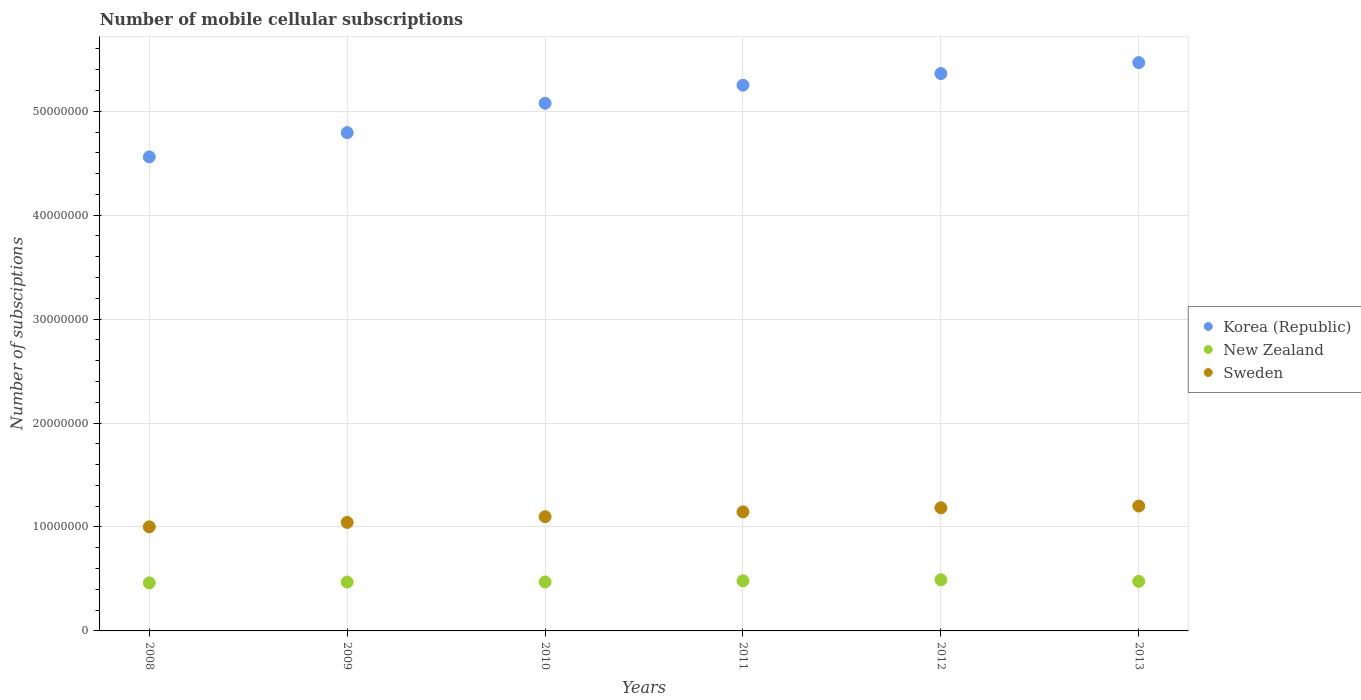What is the number of mobile cellular subscriptions in Sweden in 2013?
Provide a short and direct response. 1.20e+07. Across all years, what is the maximum number of mobile cellular subscriptions in New Zealand?
Your response must be concise. 4.92e+06. Across all years, what is the minimum number of mobile cellular subscriptions in Sweden?
Keep it short and to the point. 1.00e+07. In which year was the number of mobile cellular subscriptions in Korea (Republic) maximum?
Provide a succinct answer. 2013. What is the total number of mobile cellular subscriptions in Sweden in the graph?
Offer a terse response. 6.68e+07. What is the difference between the number of mobile cellular subscriptions in Korea (Republic) in 2010 and that in 2013?
Provide a succinct answer. -3.91e+06. What is the difference between the number of mobile cellular subscriptions in New Zealand in 2013 and the number of mobile cellular subscriptions in Sweden in 2009?
Offer a very short reply. -5.67e+06. What is the average number of mobile cellular subscriptions in Sweden per year?
Provide a short and direct response. 1.11e+07. In the year 2008, what is the difference between the number of mobile cellular subscriptions in Korea (Republic) and number of mobile cellular subscriptions in Sweden?
Your answer should be compact. 3.56e+07. What is the ratio of the number of mobile cellular subscriptions in New Zealand in 2008 to that in 2010?
Your response must be concise. 0.98. Is the number of mobile cellular subscriptions in Korea (Republic) in 2008 less than that in 2009?
Provide a succinct answer. Yes. Is the difference between the number of mobile cellular subscriptions in Korea (Republic) in 2009 and 2013 greater than the difference between the number of mobile cellular subscriptions in Sweden in 2009 and 2013?
Provide a succinct answer. No. What is the difference between the highest and the second highest number of mobile cellular subscriptions in Korea (Republic)?
Offer a terse response. 1.06e+06. What is the difference between the highest and the lowest number of mobile cellular subscriptions in Sweden?
Offer a very short reply. 2.00e+06. Is the sum of the number of mobile cellular subscriptions in Korea (Republic) in 2008 and 2012 greater than the maximum number of mobile cellular subscriptions in New Zealand across all years?
Ensure brevity in your answer.  Yes. Does the number of mobile cellular subscriptions in Sweden monotonically increase over the years?
Give a very brief answer. Yes. Is the number of mobile cellular subscriptions in Sweden strictly greater than the number of mobile cellular subscriptions in Korea (Republic) over the years?
Provide a short and direct response. No. Is the number of mobile cellular subscriptions in Korea (Republic) strictly less than the number of mobile cellular subscriptions in New Zealand over the years?
Offer a very short reply. No. How many years are there in the graph?
Keep it short and to the point. 6. What is the difference between two consecutive major ticks on the Y-axis?
Your answer should be very brief. 1.00e+07. How are the legend labels stacked?
Provide a succinct answer. Vertical. What is the title of the graph?
Offer a terse response. Number of mobile cellular subscriptions. What is the label or title of the Y-axis?
Your response must be concise. Number of subsciptions. What is the Number of subsciptions in Korea (Republic) in 2008?
Provide a succinct answer. 4.56e+07. What is the Number of subsciptions in New Zealand in 2008?
Ensure brevity in your answer.  4.62e+06. What is the Number of subsciptions of Sweden in 2008?
Ensure brevity in your answer.  1.00e+07. What is the Number of subsciptions in Korea (Republic) in 2009?
Your answer should be compact. 4.79e+07. What is the Number of subsciptions of New Zealand in 2009?
Offer a very short reply. 4.70e+06. What is the Number of subsciptions of Sweden in 2009?
Give a very brief answer. 1.04e+07. What is the Number of subsciptions of Korea (Republic) in 2010?
Your answer should be compact. 5.08e+07. What is the Number of subsciptions in New Zealand in 2010?
Keep it short and to the point. 4.71e+06. What is the Number of subsciptions in Sweden in 2010?
Offer a terse response. 1.10e+07. What is the Number of subsciptions of Korea (Republic) in 2011?
Your response must be concise. 5.25e+07. What is the Number of subsciptions in New Zealand in 2011?
Your answer should be compact. 4.82e+06. What is the Number of subsciptions in Sweden in 2011?
Keep it short and to the point. 1.15e+07. What is the Number of subsciptions of Korea (Republic) in 2012?
Your answer should be very brief. 5.36e+07. What is the Number of subsciptions of New Zealand in 2012?
Ensure brevity in your answer.  4.92e+06. What is the Number of subsciptions of Sweden in 2012?
Provide a short and direct response. 1.18e+07. What is the Number of subsciptions in Korea (Republic) in 2013?
Give a very brief answer. 5.47e+07. What is the Number of subsciptions in New Zealand in 2013?
Offer a very short reply. 4.77e+06. What is the Number of subsciptions in Sweden in 2013?
Keep it short and to the point. 1.20e+07. Across all years, what is the maximum Number of subsciptions of Korea (Republic)?
Give a very brief answer. 5.47e+07. Across all years, what is the maximum Number of subsciptions of New Zealand?
Offer a very short reply. 4.92e+06. Across all years, what is the maximum Number of subsciptions in Sweden?
Make the answer very short. 1.20e+07. Across all years, what is the minimum Number of subsciptions of Korea (Republic)?
Keep it short and to the point. 4.56e+07. Across all years, what is the minimum Number of subsciptions in New Zealand?
Provide a short and direct response. 4.62e+06. Across all years, what is the minimum Number of subsciptions of Sweden?
Provide a succinct answer. 1.00e+07. What is the total Number of subsciptions in Korea (Republic) in the graph?
Offer a terse response. 3.05e+08. What is the total Number of subsciptions of New Zealand in the graph?
Your response must be concise. 2.85e+07. What is the total Number of subsciptions of Sweden in the graph?
Ensure brevity in your answer.  6.68e+07. What is the difference between the Number of subsciptions in Korea (Republic) in 2008 and that in 2009?
Provide a succinct answer. -2.34e+06. What is the difference between the Number of subsciptions of Sweden in 2008 and that in 2009?
Give a very brief answer. -4.26e+05. What is the difference between the Number of subsciptions of Korea (Republic) in 2008 and that in 2010?
Provide a short and direct response. -5.16e+06. What is the difference between the Number of subsciptions in New Zealand in 2008 and that in 2010?
Your answer should be very brief. -9.00e+04. What is the difference between the Number of subsciptions in Sweden in 2008 and that in 2010?
Your answer should be compact. -9.78e+05. What is the difference between the Number of subsciptions in Korea (Republic) in 2008 and that in 2011?
Keep it short and to the point. -6.90e+06. What is the difference between the Number of subsciptions in Sweden in 2008 and that in 2011?
Give a very brief answer. -1.44e+06. What is the difference between the Number of subsciptions in Korea (Republic) in 2008 and that in 2012?
Your answer should be very brief. -8.02e+06. What is the difference between the Number of subsciptions in New Zealand in 2008 and that in 2012?
Your response must be concise. -3.02e+05. What is the difference between the Number of subsciptions in Sweden in 2008 and that in 2012?
Your answer should be very brief. -1.83e+06. What is the difference between the Number of subsciptions of Korea (Republic) in 2008 and that in 2013?
Ensure brevity in your answer.  -9.07e+06. What is the difference between the Number of subsciptions of New Zealand in 2008 and that in 2013?
Your answer should be compact. -1.46e+05. What is the difference between the Number of subsciptions in Sweden in 2008 and that in 2013?
Offer a terse response. -2.00e+06. What is the difference between the Number of subsciptions in Korea (Republic) in 2009 and that in 2010?
Provide a succinct answer. -2.82e+06. What is the difference between the Number of subsciptions of Sweden in 2009 and that in 2010?
Provide a short and direct response. -5.52e+05. What is the difference between the Number of subsciptions in Korea (Republic) in 2009 and that in 2011?
Your response must be concise. -4.56e+06. What is the difference between the Number of subsciptions of New Zealand in 2009 and that in 2011?
Provide a short and direct response. -1.20e+05. What is the difference between the Number of subsciptions in Sweden in 2009 and that in 2011?
Offer a terse response. -1.01e+06. What is the difference between the Number of subsciptions in Korea (Republic) in 2009 and that in 2012?
Your answer should be very brief. -5.68e+06. What is the difference between the Number of subsciptions of New Zealand in 2009 and that in 2012?
Your response must be concise. -2.22e+05. What is the difference between the Number of subsciptions in Sweden in 2009 and that in 2012?
Keep it short and to the point. -1.41e+06. What is the difference between the Number of subsciptions in Korea (Republic) in 2009 and that in 2013?
Keep it short and to the point. -6.74e+06. What is the difference between the Number of subsciptions of New Zealand in 2009 and that in 2013?
Ensure brevity in your answer.  -6.60e+04. What is the difference between the Number of subsciptions in Sweden in 2009 and that in 2013?
Your answer should be compact. -1.57e+06. What is the difference between the Number of subsciptions in Korea (Republic) in 2010 and that in 2011?
Offer a very short reply. -1.74e+06. What is the difference between the Number of subsciptions of Sweden in 2010 and that in 2011?
Ensure brevity in your answer.  -4.62e+05. What is the difference between the Number of subsciptions of Korea (Republic) in 2010 and that in 2012?
Offer a very short reply. -2.86e+06. What is the difference between the Number of subsciptions of New Zealand in 2010 and that in 2012?
Your answer should be very brief. -2.12e+05. What is the difference between the Number of subsciptions of Sweden in 2010 and that in 2012?
Provide a succinct answer. -8.56e+05. What is the difference between the Number of subsciptions in Korea (Republic) in 2010 and that in 2013?
Provide a succinct answer. -3.91e+06. What is the difference between the Number of subsciptions in New Zealand in 2010 and that in 2013?
Make the answer very short. -5.60e+04. What is the difference between the Number of subsciptions in Sweden in 2010 and that in 2013?
Your response must be concise. -1.02e+06. What is the difference between the Number of subsciptions in Korea (Republic) in 2011 and that in 2012?
Offer a terse response. -1.12e+06. What is the difference between the Number of subsciptions in New Zealand in 2011 and that in 2012?
Keep it short and to the point. -1.02e+05. What is the difference between the Number of subsciptions in Sweden in 2011 and that in 2012?
Give a very brief answer. -3.94e+05. What is the difference between the Number of subsciptions of Korea (Republic) in 2011 and that in 2013?
Provide a succinct answer. -2.17e+06. What is the difference between the Number of subsciptions of New Zealand in 2011 and that in 2013?
Your answer should be very brief. 5.40e+04. What is the difference between the Number of subsciptions in Sweden in 2011 and that in 2013?
Make the answer very short. -5.60e+05. What is the difference between the Number of subsciptions in Korea (Republic) in 2012 and that in 2013?
Your answer should be very brief. -1.06e+06. What is the difference between the Number of subsciptions of New Zealand in 2012 and that in 2013?
Your response must be concise. 1.56e+05. What is the difference between the Number of subsciptions in Sweden in 2012 and that in 2013?
Provide a succinct answer. -1.66e+05. What is the difference between the Number of subsciptions in Korea (Republic) in 2008 and the Number of subsciptions in New Zealand in 2009?
Provide a short and direct response. 4.09e+07. What is the difference between the Number of subsciptions of Korea (Republic) in 2008 and the Number of subsciptions of Sweden in 2009?
Provide a short and direct response. 3.52e+07. What is the difference between the Number of subsciptions in New Zealand in 2008 and the Number of subsciptions in Sweden in 2009?
Your answer should be very brief. -5.82e+06. What is the difference between the Number of subsciptions in Korea (Republic) in 2008 and the Number of subsciptions in New Zealand in 2010?
Your answer should be very brief. 4.09e+07. What is the difference between the Number of subsciptions of Korea (Republic) in 2008 and the Number of subsciptions of Sweden in 2010?
Ensure brevity in your answer.  3.46e+07. What is the difference between the Number of subsciptions in New Zealand in 2008 and the Number of subsciptions in Sweden in 2010?
Make the answer very short. -6.37e+06. What is the difference between the Number of subsciptions of Korea (Republic) in 2008 and the Number of subsciptions of New Zealand in 2011?
Your answer should be compact. 4.08e+07. What is the difference between the Number of subsciptions in Korea (Republic) in 2008 and the Number of subsciptions in Sweden in 2011?
Offer a very short reply. 3.42e+07. What is the difference between the Number of subsciptions in New Zealand in 2008 and the Number of subsciptions in Sweden in 2011?
Keep it short and to the point. -6.83e+06. What is the difference between the Number of subsciptions in Korea (Republic) in 2008 and the Number of subsciptions in New Zealand in 2012?
Your response must be concise. 4.07e+07. What is the difference between the Number of subsciptions in Korea (Republic) in 2008 and the Number of subsciptions in Sweden in 2012?
Keep it short and to the point. 3.38e+07. What is the difference between the Number of subsciptions of New Zealand in 2008 and the Number of subsciptions of Sweden in 2012?
Your response must be concise. -7.23e+06. What is the difference between the Number of subsciptions in Korea (Republic) in 2008 and the Number of subsciptions in New Zealand in 2013?
Make the answer very short. 4.08e+07. What is the difference between the Number of subsciptions in Korea (Republic) in 2008 and the Number of subsciptions in Sweden in 2013?
Your answer should be compact. 3.36e+07. What is the difference between the Number of subsciptions of New Zealand in 2008 and the Number of subsciptions of Sweden in 2013?
Ensure brevity in your answer.  -7.39e+06. What is the difference between the Number of subsciptions of Korea (Republic) in 2009 and the Number of subsciptions of New Zealand in 2010?
Make the answer very short. 4.32e+07. What is the difference between the Number of subsciptions of Korea (Republic) in 2009 and the Number of subsciptions of Sweden in 2010?
Ensure brevity in your answer.  3.70e+07. What is the difference between the Number of subsciptions of New Zealand in 2009 and the Number of subsciptions of Sweden in 2010?
Make the answer very short. -6.29e+06. What is the difference between the Number of subsciptions in Korea (Republic) in 2009 and the Number of subsciptions in New Zealand in 2011?
Make the answer very short. 4.31e+07. What is the difference between the Number of subsciptions in Korea (Republic) in 2009 and the Number of subsciptions in Sweden in 2011?
Keep it short and to the point. 3.65e+07. What is the difference between the Number of subsciptions in New Zealand in 2009 and the Number of subsciptions in Sweden in 2011?
Make the answer very short. -6.75e+06. What is the difference between the Number of subsciptions of Korea (Republic) in 2009 and the Number of subsciptions of New Zealand in 2012?
Your response must be concise. 4.30e+07. What is the difference between the Number of subsciptions in Korea (Republic) in 2009 and the Number of subsciptions in Sweden in 2012?
Make the answer very short. 3.61e+07. What is the difference between the Number of subsciptions in New Zealand in 2009 and the Number of subsciptions in Sweden in 2012?
Your answer should be compact. -7.15e+06. What is the difference between the Number of subsciptions in Korea (Republic) in 2009 and the Number of subsciptions in New Zealand in 2013?
Your response must be concise. 4.32e+07. What is the difference between the Number of subsciptions in Korea (Republic) in 2009 and the Number of subsciptions in Sweden in 2013?
Make the answer very short. 3.59e+07. What is the difference between the Number of subsciptions of New Zealand in 2009 and the Number of subsciptions of Sweden in 2013?
Keep it short and to the point. -7.31e+06. What is the difference between the Number of subsciptions of Korea (Republic) in 2010 and the Number of subsciptions of New Zealand in 2011?
Offer a very short reply. 4.59e+07. What is the difference between the Number of subsciptions in Korea (Republic) in 2010 and the Number of subsciptions in Sweden in 2011?
Offer a terse response. 3.93e+07. What is the difference between the Number of subsciptions in New Zealand in 2010 and the Number of subsciptions in Sweden in 2011?
Your answer should be very brief. -6.74e+06. What is the difference between the Number of subsciptions of Korea (Republic) in 2010 and the Number of subsciptions of New Zealand in 2012?
Offer a very short reply. 4.58e+07. What is the difference between the Number of subsciptions in Korea (Republic) in 2010 and the Number of subsciptions in Sweden in 2012?
Keep it short and to the point. 3.89e+07. What is the difference between the Number of subsciptions of New Zealand in 2010 and the Number of subsciptions of Sweden in 2012?
Your response must be concise. -7.14e+06. What is the difference between the Number of subsciptions in Korea (Republic) in 2010 and the Number of subsciptions in New Zealand in 2013?
Provide a succinct answer. 4.60e+07. What is the difference between the Number of subsciptions in Korea (Republic) in 2010 and the Number of subsciptions in Sweden in 2013?
Offer a terse response. 3.88e+07. What is the difference between the Number of subsciptions of New Zealand in 2010 and the Number of subsciptions of Sweden in 2013?
Offer a terse response. -7.30e+06. What is the difference between the Number of subsciptions in Korea (Republic) in 2011 and the Number of subsciptions in New Zealand in 2012?
Offer a very short reply. 4.76e+07. What is the difference between the Number of subsciptions of Korea (Republic) in 2011 and the Number of subsciptions of Sweden in 2012?
Offer a very short reply. 4.07e+07. What is the difference between the Number of subsciptions in New Zealand in 2011 and the Number of subsciptions in Sweden in 2012?
Offer a terse response. -7.03e+06. What is the difference between the Number of subsciptions of Korea (Republic) in 2011 and the Number of subsciptions of New Zealand in 2013?
Make the answer very short. 4.77e+07. What is the difference between the Number of subsciptions in Korea (Republic) in 2011 and the Number of subsciptions in Sweden in 2013?
Give a very brief answer. 4.05e+07. What is the difference between the Number of subsciptions in New Zealand in 2011 and the Number of subsciptions in Sweden in 2013?
Offer a very short reply. -7.19e+06. What is the difference between the Number of subsciptions of Korea (Republic) in 2012 and the Number of subsciptions of New Zealand in 2013?
Your response must be concise. 4.89e+07. What is the difference between the Number of subsciptions of Korea (Republic) in 2012 and the Number of subsciptions of Sweden in 2013?
Offer a very short reply. 4.16e+07. What is the difference between the Number of subsciptions in New Zealand in 2012 and the Number of subsciptions in Sweden in 2013?
Give a very brief answer. -7.09e+06. What is the average Number of subsciptions of Korea (Republic) per year?
Ensure brevity in your answer.  5.09e+07. What is the average Number of subsciptions in New Zealand per year?
Offer a very short reply. 4.76e+06. What is the average Number of subsciptions in Sweden per year?
Give a very brief answer. 1.11e+07. In the year 2008, what is the difference between the Number of subsciptions of Korea (Republic) and Number of subsciptions of New Zealand?
Make the answer very short. 4.10e+07. In the year 2008, what is the difference between the Number of subsciptions of Korea (Republic) and Number of subsciptions of Sweden?
Make the answer very short. 3.56e+07. In the year 2008, what is the difference between the Number of subsciptions of New Zealand and Number of subsciptions of Sweden?
Your response must be concise. -5.39e+06. In the year 2009, what is the difference between the Number of subsciptions of Korea (Republic) and Number of subsciptions of New Zealand?
Give a very brief answer. 4.32e+07. In the year 2009, what is the difference between the Number of subsciptions in Korea (Republic) and Number of subsciptions in Sweden?
Provide a succinct answer. 3.75e+07. In the year 2009, what is the difference between the Number of subsciptions of New Zealand and Number of subsciptions of Sweden?
Your response must be concise. -5.74e+06. In the year 2010, what is the difference between the Number of subsciptions of Korea (Republic) and Number of subsciptions of New Zealand?
Provide a succinct answer. 4.61e+07. In the year 2010, what is the difference between the Number of subsciptions in Korea (Republic) and Number of subsciptions in Sweden?
Give a very brief answer. 3.98e+07. In the year 2010, what is the difference between the Number of subsciptions in New Zealand and Number of subsciptions in Sweden?
Provide a short and direct response. -6.28e+06. In the year 2011, what is the difference between the Number of subsciptions of Korea (Republic) and Number of subsciptions of New Zealand?
Provide a succinct answer. 4.77e+07. In the year 2011, what is the difference between the Number of subsciptions in Korea (Republic) and Number of subsciptions in Sweden?
Make the answer very short. 4.11e+07. In the year 2011, what is the difference between the Number of subsciptions in New Zealand and Number of subsciptions in Sweden?
Offer a terse response. -6.63e+06. In the year 2012, what is the difference between the Number of subsciptions in Korea (Republic) and Number of subsciptions in New Zealand?
Your answer should be compact. 4.87e+07. In the year 2012, what is the difference between the Number of subsciptions of Korea (Republic) and Number of subsciptions of Sweden?
Keep it short and to the point. 4.18e+07. In the year 2012, what is the difference between the Number of subsciptions in New Zealand and Number of subsciptions in Sweden?
Provide a short and direct response. -6.93e+06. In the year 2013, what is the difference between the Number of subsciptions in Korea (Republic) and Number of subsciptions in New Zealand?
Your answer should be very brief. 4.99e+07. In the year 2013, what is the difference between the Number of subsciptions in Korea (Republic) and Number of subsciptions in Sweden?
Keep it short and to the point. 4.27e+07. In the year 2013, what is the difference between the Number of subsciptions in New Zealand and Number of subsciptions in Sweden?
Keep it short and to the point. -7.25e+06. What is the ratio of the Number of subsciptions of Korea (Republic) in 2008 to that in 2009?
Your answer should be compact. 0.95. What is the ratio of the Number of subsciptions in Sweden in 2008 to that in 2009?
Provide a succinct answer. 0.96. What is the ratio of the Number of subsciptions in Korea (Republic) in 2008 to that in 2010?
Give a very brief answer. 0.9. What is the ratio of the Number of subsciptions of New Zealand in 2008 to that in 2010?
Keep it short and to the point. 0.98. What is the ratio of the Number of subsciptions of Sweden in 2008 to that in 2010?
Provide a short and direct response. 0.91. What is the ratio of the Number of subsciptions in Korea (Republic) in 2008 to that in 2011?
Your answer should be very brief. 0.87. What is the ratio of the Number of subsciptions of New Zealand in 2008 to that in 2011?
Your answer should be very brief. 0.96. What is the ratio of the Number of subsciptions in Sweden in 2008 to that in 2011?
Ensure brevity in your answer.  0.87. What is the ratio of the Number of subsciptions of Korea (Republic) in 2008 to that in 2012?
Offer a terse response. 0.85. What is the ratio of the Number of subsciptions of New Zealand in 2008 to that in 2012?
Your answer should be compact. 0.94. What is the ratio of the Number of subsciptions of Sweden in 2008 to that in 2012?
Offer a very short reply. 0.85. What is the ratio of the Number of subsciptions of Korea (Republic) in 2008 to that in 2013?
Provide a short and direct response. 0.83. What is the ratio of the Number of subsciptions of New Zealand in 2008 to that in 2013?
Offer a very short reply. 0.97. What is the ratio of the Number of subsciptions in Sweden in 2008 to that in 2013?
Make the answer very short. 0.83. What is the ratio of the Number of subsciptions in Korea (Republic) in 2009 to that in 2010?
Offer a terse response. 0.94. What is the ratio of the Number of subsciptions of Sweden in 2009 to that in 2010?
Offer a very short reply. 0.95. What is the ratio of the Number of subsciptions in Korea (Republic) in 2009 to that in 2011?
Provide a short and direct response. 0.91. What is the ratio of the Number of subsciptions of New Zealand in 2009 to that in 2011?
Give a very brief answer. 0.98. What is the ratio of the Number of subsciptions of Sweden in 2009 to that in 2011?
Your answer should be very brief. 0.91. What is the ratio of the Number of subsciptions in Korea (Republic) in 2009 to that in 2012?
Make the answer very short. 0.89. What is the ratio of the Number of subsciptions of New Zealand in 2009 to that in 2012?
Provide a short and direct response. 0.95. What is the ratio of the Number of subsciptions of Sweden in 2009 to that in 2012?
Provide a short and direct response. 0.88. What is the ratio of the Number of subsciptions in Korea (Republic) in 2009 to that in 2013?
Offer a terse response. 0.88. What is the ratio of the Number of subsciptions of New Zealand in 2009 to that in 2013?
Provide a short and direct response. 0.99. What is the ratio of the Number of subsciptions of Sweden in 2009 to that in 2013?
Offer a terse response. 0.87. What is the ratio of the Number of subsciptions of Korea (Republic) in 2010 to that in 2011?
Provide a succinct answer. 0.97. What is the ratio of the Number of subsciptions of New Zealand in 2010 to that in 2011?
Offer a terse response. 0.98. What is the ratio of the Number of subsciptions in Sweden in 2010 to that in 2011?
Make the answer very short. 0.96. What is the ratio of the Number of subsciptions of Korea (Republic) in 2010 to that in 2012?
Your answer should be very brief. 0.95. What is the ratio of the Number of subsciptions in New Zealand in 2010 to that in 2012?
Make the answer very short. 0.96. What is the ratio of the Number of subsciptions of Sweden in 2010 to that in 2012?
Keep it short and to the point. 0.93. What is the ratio of the Number of subsciptions of Korea (Republic) in 2010 to that in 2013?
Offer a terse response. 0.93. What is the ratio of the Number of subsciptions in New Zealand in 2010 to that in 2013?
Offer a terse response. 0.99. What is the ratio of the Number of subsciptions in Sweden in 2010 to that in 2013?
Ensure brevity in your answer.  0.91. What is the ratio of the Number of subsciptions in Korea (Republic) in 2011 to that in 2012?
Offer a very short reply. 0.98. What is the ratio of the Number of subsciptions of New Zealand in 2011 to that in 2012?
Your response must be concise. 0.98. What is the ratio of the Number of subsciptions in Sweden in 2011 to that in 2012?
Provide a short and direct response. 0.97. What is the ratio of the Number of subsciptions of Korea (Republic) in 2011 to that in 2013?
Offer a terse response. 0.96. What is the ratio of the Number of subsciptions of New Zealand in 2011 to that in 2013?
Your answer should be compact. 1.01. What is the ratio of the Number of subsciptions of Sweden in 2011 to that in 2013?
Your answer should be compact. 0.95. What is the ratio of the Number of subsciptions in Korea (Republic) in 2012 to that in 2013?
Offer a terse response. 0.98. What is the ratio of the Number of subsciptions of New Zealand in 2012 to that in 2013?
Provide a succinct answer. 1.03. What is the ratio of the Number of subsciptions in Sweden in 2012 to that in 2013?
Ensure brevity in your answer.  0.99. What is the difference between the highest and the second highest Number of subsciptions of Korea (Republic)?
Provide a succinct answer. 1.06e+06. What is the difference between the highest and the second highest Number of subsciptions in New Zealand?
Make the answer very short. 1.02e+05. What is the difference between the highest and the second highest Number of subsciptions in Sweden?
Offer a terse response. 1.66e+05. What is the difference between the highest and the lowest Number of subsciptions of Korea (Republic)?
Provide a succinct answer. 9.07e+06. What is the difference between the highest and the lowest Number of subsciptions in New Zealand?
Give a very brief answer. 3.02e+05. What is the difference between the highest and the lowest Number of subsciptions of Sweden?
Offer a very short reply. 2.00e+06. 